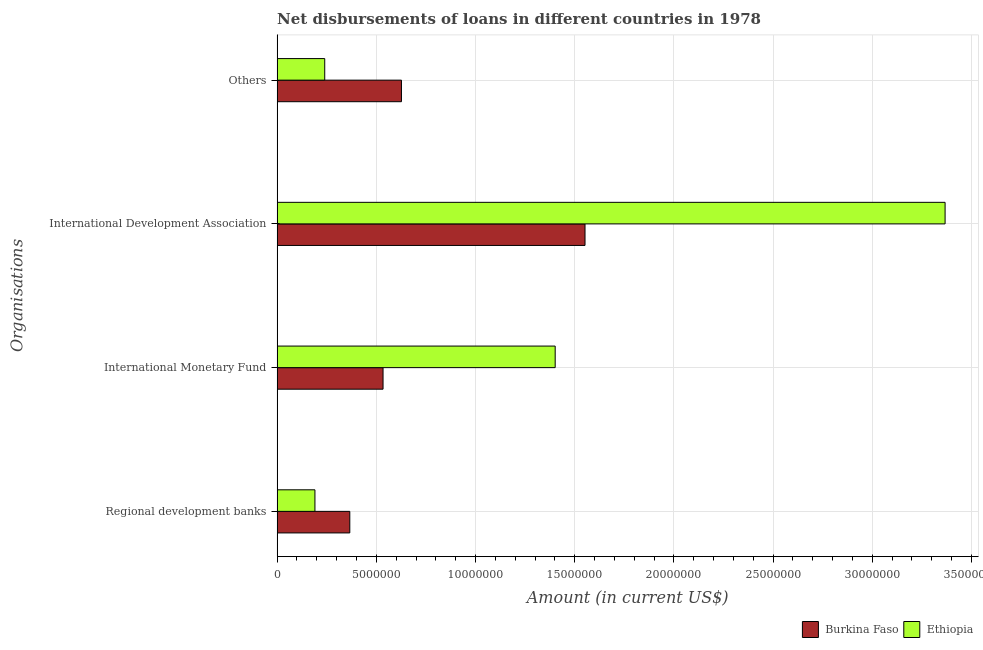What is the label of the 1st group of bars from the top?
Your response must be concise. Others. What is the amount of loan disimbursed by international monetary fund in Burkina Faso?
Your answer should be very brief. 5.34e+06. Across all countries, what is the maximum amount of loan disimbursed by international development association?
Keep it short and to the point. 3.37e+07. Across all countries, what is the minimum amount of loan disimbursed by international development association?
Make the answer very short. 1.55e+07. In which country was the amount of loan disimbursed by international monetary fund maximum?
Give a very brief answer. Ethiopia. In which country was the amount of loan disimbursed by other organisations minimum?
Offer a terse response. Ethiopia. What is the total amount of loan disimbursed by international monetary fund in the graph?
Your answer should be very brief. 1.94e+07. What is the difference between the amount of loan disimbursed by international monetary fund in Burkina Faso and that in Ethiopia?
Give a very brief answer. -8.68e+06. What is the difference between the amount of loan disimbursed by international development association in Burkina Faso and the amount of loan disimbursed by international monetary fund in Ethiopia?
Give a very brief answer. 1.50e+06. What is the average amount of loan disimbursed by international development association per country?
Give a very brief answer. 2.46e+07. What is the difference between the amount of loan disimbursed by regional development banks and amount of loan disimbursed by other organisations in Ethiopia?
Offer a terse response. -4.94e+05. What is the ratio of the amount of loan disimbursed by regional development banks in Ethiopia to that in Burkina Faso?
Offer a terse response. 0.52. Is the amount of loan disimbursed by international monetary fund in Burkina Faso less than that in Ethiopia?
Keep it short and to the point. Yes. Is the difference between the amount of loan disimbursed by other organisations in Burkina Faso and Ethiopia greater than the difference between the amount of loan disimbursed by international monetary fund in Burkina Faso and Ethiopia?
Your response must be concise. Yes. What is the difference between the highest and the second highest amount of loan disimbursed by international monetary fund?
Provide a succinct answer. 8.68e+06. What is the difference between the highest and the lowest amount of loan disimbursed by regional development banks?
Provide a succinct answer. 1.76e+06. In how many countries, is the amount of loan disimbursed by regional development banks greater than the average amount of loan disimbursed by regional development banks taken over all countries?
Make the answer very short. 1. What does the 1st bar from the top in Regional development banks represents?
Offer a very short reply. Ethiopia. What does the 1st bar from the bottom in Regional development banks represents?
Your answer should be very brief. Burkina Faso. Are all the bars in the graph horizontal?
Provide a succinct answer. Yes. What is the difference between two consecutive major ticks on the X-axis?
Make the answer very short. 5.00e+06. Does the graph contain grids?
Ensure brevity in your answer.  Yes. Where does the legend appear in the graph?
Ensure brevity in your answer.  Bottom right. What is the title of the graph?
Provide a short and direct response. Net disbursements of loans in different countries in 1978. What is the label or title of the Y-axis?
Your answer should be very brief. Organisations. What is the Amount (in current US$) in Burkina Faso in Regional development banks?
Your answer should be very brief. 3.66e+06. What is the Amount (in current US$) in Ethiopia in Regional development banks?
Your answer should be compact. 1.91e+06. What is the Amount (in current US$) in Burkina Faso in International Monetary Fund?
Provide a succinct answer. 5.34e+06. What is the Amount (in current US$) of Ethiopia in International Monetary Fund?
Your answer should be very brief. 1.40e+07. What is the Amount (in current US$) of Burkina Faso in International Development Association?
Offer a very short reply. 1.55e+07. What is the Amount (in current US$) of Ethiopia in International Development Association?
Your response must be concise. 3.37e+07. What is the Amount (in current US$) in Burkina Faso in Others?
Offer a very short reply. 6.27e+06. What is the Amount (in current US$) of Ethiopia in Others?
Ensure brevity in your answer.  2.40e+06. Across all Organisations, what is the maximum Amount (in current US$) of Burkina Faso?
Give a very brief answer. 1.55e+07. Across all Organisations, what is the maximum Amount (in current US$) of Ethiopia?
Keep it short and to the point. 3.37e+07. Across all Organisations, what is the minimum Amount (in current US$) of Burkina Faso?
Your answer should be compact. 3.66e+06. Across all Organisations, what is the minimum Amount (in current US$) in Ethiopia?
Offer a terse response. 1.91e+06. What is the total Amount (in current US$) in Burkina Faso in the graph?
Your answer should be compact. 3.08e+07. What is the total Amount (in current US$) of Ethiopia in the graph?
Provide a short and direct response. 5.20e+07. What is the difference between the Amount (in current US$) in Burkina Faso in Regional development banks and that in International Monetary Fund?
Ensure brevity in your answer.  -1.68e+06. What is the difference between the Amount (in current US$) of Ethiopia in Regional development banks and that in International Monetary Fund?
Offer a terse response. -1.21e+07. What is the difference between the Amount (in current US$) of Burkina Faso in Regional development banks and that in International Development Association?
Keep it short and to the point. -1.19e+07. What is the difference between the Amount (in current US$) of Ethiopia in Regional development banks and that in International Development Association?
Your answer should be compact. -3.18e+07. What is the difference between the Amount (in current US$) in Burkina Faso in Regional development banks and that in Others?
Give a very brief answer. -2.60e+06. What is the difference between the Amount (in current US$) in Ethiopia in Regional development banks and that in Others?
Your answer should be very brief. -4.94e+05. What is the difference between the Amount (in current US$) of Burkina Faso in International Monetary Fund and that in International Development Association?
Give a very brief answer. -1.02e+07. What is the difference between the Amount (in current US$) in Ethiopia in International Monetary Fund and that in International Development Association?
Your answer should be compact. -1.97e+07. What is the difference between the Amount (in current US$) of Burkina Faso in International Monetary Fund and that in Others?
Offer a terse response. -9.28e+05. What is the difference between the Amount (in current US$) of Ethiopia in International Monetary Fund and that in Others?
Provide a succinct answer. 1.16e+07. What is the difference between the Amount (in current US$) of Burkina Faso in International Development Association and that in Others?
Provide a succinct answer. 9.25e+06. What is the difference between the Amount (in current US$) in Ethiopia in International Development Association and that in Others?
Your response must be concise. 3.13e+07. What is the difference between the Amount (in current US$) in Burkina Faso in Regional development banks and the Amount (in current US$) in Ethiopia in International Monetary Fund?
Your answer should be very brief. -1.04e+07. What is the difference between the Amount (in current US$) of Burkina Faso in Regional development banks and the Amount (in current US$) of Ethiopia in International Development Association?
Provide a succinct answer. -3.00e+07. What is the difference between the Amount (in current US$) of Burkina Faso in Regional development banks and the Amount (in current US$) of Ethiopia in Others?
Keep it short and to the point. 1.26e+06. What is the difference between the Amount (in current US$) in Burkina Faso in International Monetary Fund and the Amount (in current US$) in Ethiopia in International Development Association?
Your answer should be very brief. -2.83e+07. What is the difference between the Amount (in current US$) in Burkina Faso in International Monetary Fund and the Amount (in current US$) in Ethiopia in Others?
Your answer should be compact. 2.94e+06. What is the difference between the Amount (in current US$) of Burkina Faso in International Development Association and the Amount (in current US$) of Ethiopia in Others?
Your answer should be compact. 1.31e+07. What is the average Amount (in current US$) in Burkina Faso per Organisations?
Make the answer very short. 7.70e+06. What is the average Amount (in current US$) of Ethiopia per Organisations?
Make the answer very short. 1.30e+07. What is the difference between the Amount (in current US$) in Burkina Faso and Amount (in current US$) in Ethiopia in Regional development banks?
Your answer should be compact. 1.76e+06. What is the difference between the Amount (in current US$) of Burkina Faso and Amount (in current US$) of Ethiopia in International Monetary Fund?
Offer a very short reply. -8.68e+06. What is the difference between the Amount (in current US$) in Burkina Faso and Amount (in current US$) in Ethiopia in International Development Association?
Offer a terse response. -1.82e+07. What is the difference between the Amount (in current US$) in Burkina Faso and Amount (in current US$) in Ethiopia in Others?
Give a very brief answer. 3.87e+06. What is the ratio of the Amount (in current US$) of Burkina Faso in Regional development banks to that in International Monetary Fund?
Keep it short and to the point. 0.69. What is the ratio of the Amount (in current US$) of Ethiopia in Regional development banks to that in International Monetary Fund?
Your response must be concise. 0.14. What is the ratio of the Amount (in current US$) of Burkina Faso in Regional development banks to that in International Development Association?
Make the answer very short. 0.24. What is the ratio of the Amount (in current US$) of Ethiopia in Regional development banks to that in International Development Association?
Your response must be concise. 0.06. What is the ratio of the Amount (in current US$) of Burkina Faso in Regional development banks to that in Others?
Your answer should be compact. 0.58. What is the ratio of the Amount (in current US$) of Ethiopia in Regional development banks to that in Others?
Offer a very short reply. 0.79. What is the ratio of the Amount (in current US$) in Burkina Faso in International Monetary Fund to that in International Development Association?
Your response must be concise. 0.34. What is the ratio of the Amount (in current US$) of Ethiopia in International Monetary Fund to that in International Development Association?
Provide a succinct answer. 0.42. What is the ratio of the Amount (in current US$) of Burkina Faso in International Monetary Fund to that in Others?
Provide a short and direct response. 0.85. What is the ratio of the Amount (in current US$) in Ethiopia in International Monetary Fund to that in Others?
Provide a short and direct response. 5.84. What is the ratio of the Amount (in current US$) in Burkina Faso in International Development Association to that in Others?
Offer a terse response. 2.48. What is the ratio of the Amount (in current US$) of Ethiopia in International Development Association to that in Others?
Offer a very short reply. 14.03. What is the difference between the highest and the second highest Amount (in current US$) in Burkina Faso?
Offer a terse response. 9.25e+06. What is the difference between the highest and the second highest Amount (in current US$) in Ethiopia?
Your answer should be compact. 1.97e+07. What is the difference between the highest and the lowest Amount (in current US$) in Burkina Faso?
Make the answer very short. 1.19e+07. What is the difference between the highest and the lowest Amount (in current US$) of Ethiopia?
Offer a very short reply. 3.18e+07. 